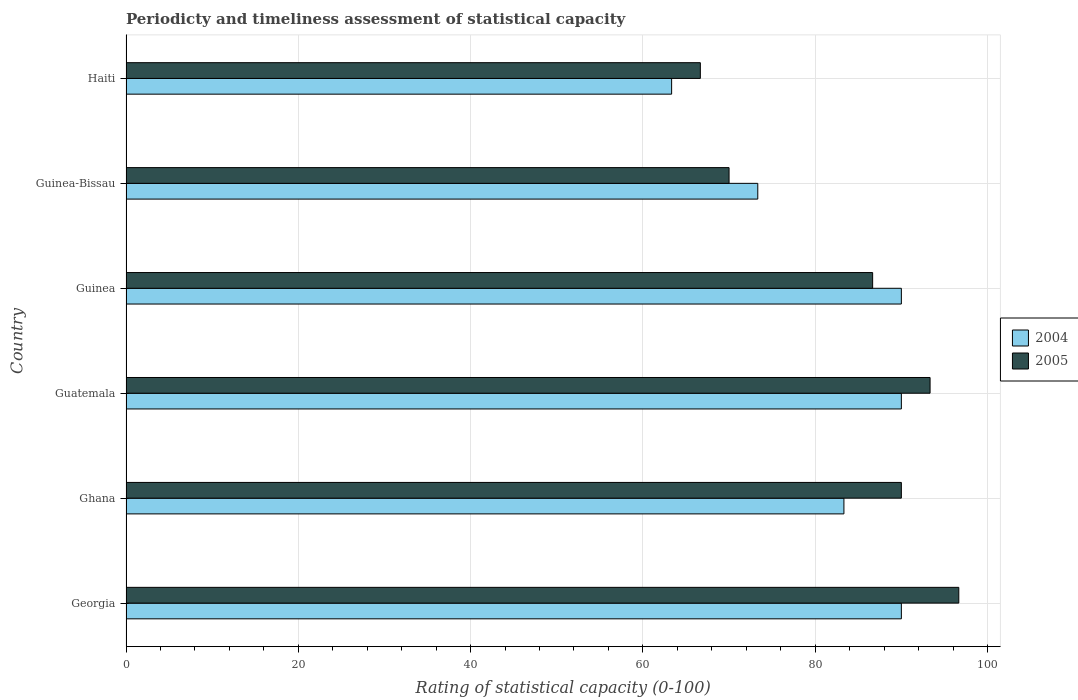How many groups of bars are there?
Make the answer very short. 6. Are the number of bars per tick equal to the number of legend labels?
Make the answer very short. Yes. How many bars are there on the 5th tick from the top?
Ensure brevity in your answer.  2. What is the label of the 2nd group of bars from the top?
Your answer should be compact. Guinea-Bissau. In how many cases, is the number of bars for a given country not equal to the number of legend labels?
Keep it short and to the point. 0. What is the rating of statistical capacity in 2005 in Ghana?
Offer a very short reply. 90. Across all countries, what is the maximum rating of statistical capacity in 2005?
Offer a very short reply. 96.67. Across all countries, what is the minimum rating of statistical capacity in 2004?
Your answer should be very brief. 63.33. In which country was the rating of statistical capacity in 2004 maximum?
Your response must be concise. Georgia. In which country was the rating of statistical capacity in 2004 minimum?
Ensure brevity in your answer.  Haiti. What is the total rating of statistical capacity in 2005 in the graph?
Offer a very short reply. 503.33. What is the difference between the rating of statistical capacity in 2005 in Haiti and the rating of statistical capacity in 2004 in Georgia?
Provide a short and direct response. -23.33. What is the average rating of statistical capacity in 2005 per country?
Provide a succinct answer. 83.89. What is the difference between the rating of statistical capacity in 2005 and rating of statistical capacity in 2004 in Guatemala?
Offer a very short reply. 3.33. What is the ratio of the rating of statistical capacity in 2004 in Georgia to that in Ghana?
Your answer should be compact. 1.08. What is the difference between the highest and the second highest rating of statistical capacity in 2005?
Provide a succinct answer. 3.33. What is the difference between the highest and the lowest rating of statistical capacity in 2004?
Your answer should be compact. 26.67. What does the 2nd bar from the bottom in Guinea represents?
Offer a terse response. 2005. Are the values on the major ticks of X-axis written in scientific E-notation?
Give a very brief answer. No. Does the graph contain grids?
Keep it short and to the point. Yes. How many legend labels are there?
Offer a very short reply. 2. What is the title of the graph?
Give a very brief answer. Periodicty and timeliness assessment of statistical capacity. Does "1986" appear as one of the legend labels in the graph?
Offer a very short reply. No. What is the label or title of the X-axis?
Offer a terse response. Rating of statistical capacity (0-100). What is the label or title of the Y-axis?
Your answer should be compact. Country. What is the Rating of statistical capacity (0-100) in 2004 in Georgia?
Keep it short and to the point. 90. What is the Rating of statistical capacity (0-100) in 2005 in Georgia?
Give a very brief answer. 96.67. What is the Rating of statistical capacity (0-100) in 2004 in Ghana?
Provide a succinct answer. 83.33. What is the Rating of statistical capacity (0-100) in 2005 in Ghana?
Offer a terse response. 90. What is the Rating of statistical capacity (0-100) of 2005 in Guatemala?
Ensure brevity in your answer.  93.33. What is the Rating of statistical capacity (0-100) of 2004 in Guinea?
Make the answer very short. 90. What is the Rating of statistical capacity (0-100) of 2005 in Guinea?
Your answer should be very brief. 86.67. What is the Rating of statistical capacity (0-100) in 2004 in Guinea-Bissau?
Ensure brevity in your answer.  73.33. What is the Rating of statistical capacity (0-100) in 2005 in Guinea-Bissau?
Your answer should be compact. 70. What is the Rating of statistical capacity (0-100) in 2004 in Haiti?
Make the answer very short. 63.33. What is the Rating of statistical capacity (0-100) of 2005 in Haiti?
Your response must be concise. 66.67. Across all countries, what is the maximum Rating of statistical capacity (0-100) of 2005?
Provide a short and direct response. 96.67. Across all countries, what is the minimum Rating of statistical capacity (0-100) in 2004?
Provide a short and direct response. 63.33. Across all countries, what is the minimum Rating of statistical capacity (0-100) of 2005?
Your answer should be very brief. 66.67. What is the total Rating of statistical capacity (0-100) in 2004 in the graph?
Keep it short and to the point. 490. What is the total Rating of statistical capacity (0-100) in 2005 in the graph?
Your answer should be compact. 503.33. What is the difference between the Rating of statistical capacity (0-100) in 2004 in Georgia and that in Guatemala?
Offer a terse response. 0. What is the difference between the Rating of statistical capacity (0-100) in 2004 in Georgia and that in Guinea?
Provide a succinct answer. 0. What is the difference between the Rating of statistical capacity (0-100) of 2004 in Georgia and that in Guinea-Bissau?
Provide a succinct answer. 16.67. What is the difference between the Rating of statistical capacity (0-100) of 2005 in Georgia and that in Guinea-Bissau?
Offer a very short reply. 26.67. What is the difference between the Rating of statistical capacity (0-100) in 2004 in Georgia and that in Haiti?
Offer a very short reply. 26.67. What is the difference between the Rating of statistical capacity (0-100) of 2005 in Georgia and that in Haiti?
Provide a succinct answer. 30. What is the difference between the Rating of statistical capacity (0-100) in 2004 in Ghana and that in Guatemala?
Keep it short and to the point. -6.67. What is the difference between the Rating of statistical capacity (0-100) of 2004 in Ghana and that in Guinea?
Provide a short and direct response. -6.67. What is the difference between the Rating of statistical capacity (0-100) of 2005 in Ghana and that in Guinea?
Offer a terse response. 3.33. What is the difference between the Rating of statistical capacity (0-100) in 2005 in Ghana and that in Guinea-Bissau?
Ensure brevity in your answer.  20. What is the difference between the Rating of statistical capacity (0-100) of 2005 in Ghana and that in Haiti?
Provide a succinct answer. 23.33. What is the difference between the Rating of statistical capacity (0-100) of 2005 in Guatemala and that in Guinea?
Offer a terse response. 6.67. What is the difference between the Rating of statistical capacity (0-100) of 2004 in Guatemala and that in Guinea-Bissau?
Provide a succinct answer. 16.67. What is the difference between the Rating of statistical capacity (0-100) of 2005 in Guatemala and that in Guinea-Bissau?
Offer a terse response. 23.33. What is the difference between the Rating of statistical capacity (0-100) of 2004 in Guatemala and that in Haiti?
Keep it short and to the point. 26.67. What is the difference between the Rating of statistical capacity (0-100) in 2005 in Guatemala and that in Haiti?
Ensure brevity in your answer.  26.67. What is the difference between the Rating of statistical capacity (0-100) of 2004 in Guinea and that in Guinea-Bissau?
Keep it short and to the point. 16.67. What is the difference between the Rating of statistical capacity (0-100) in 2005 in Guinea and that in Guinea-Bissau?
Give a very brief answer. 16.67. What is the difference between the Rating of statistical capacity (0-100) in 2004 in Guinea and that in Haiti?
Keep it short and to the point. 26.67. What is the difference between the Rating of statistical capacity (0-100) in 2005 in Guinea-Bissau and that in Haiti?
Keep it short and to the point. 3.33. What is the difference between the Rating of statistical capacity (0-100) of 2004 in Georgia and the Rating of statistical capacity (0-100) of 2005 in Guinea?
Provide a short and direct response. 3.33. What is the difference between the Rating of statistical capacity (0-100) in 2004 in Georgia and the Rating of statistical capacity (0-100) in 2005 in Guinea-Bissau?
Your response must be concise. 20. What is the difference between the Rating of statistical capacity (0-100) of 2004 in Georgia and the Rating of statistical capacity (0-100) of 2005 in Haiti?
Make the answer very short. 23.33. What is the difference between the Rating of statistical capacity (0-100) in 2004 in Ghana and the Rating of statistical capacity (0-100) in 2005 in Guinea-Bissau?
Offer a terse response. 13.33. What is the difference between the Rating of statistical capacity (0-100) of 2004 in Ghana and the Rating of statistical capacity (0-100) of 2005 in Haiti?
Your answer should be compact. 16.67. What is the difference between the Rating of statistical capacity (0-100) of 2004 in Guatemala and the Rating of statistical capacity (0-100) of 2005 in Haiti?
Your answer should be compact. 23.33. What is the difference between the Rating of statistical capacity (0-100) in 2004 in Guinea and the Rating of statistical capacity (0-100) in 2005 in Guinea-Bissau?
Offer a very short reply. 20. What is the difference between the Rating of statistical capacity (0-100) of 2004 in Guinea and the Rating of statistical capacity (0-100) of 2005 in Haiti?
Offer a terse response. 23.33. What is the difference between the Rating of statistical capacity (0-100) in 2004 in Guinea-Bissau and the Rating of statistical capacity (0-100) in 2005 in Haiti?
Offer a very short reply. 6.67. What is the average Rating of statistical capacity (0-100) in 2004 per country?
Make the answer very short. 81.67. What is the average Rating of statistical capacity (0-100) of 2005 per country?
Your response must be concise. 83.89. What is the difference between the Rating of statistical capacity (0-100) of 2004 and Rating of statistical capacity (0-100) of 2005 in Georgia?
Your response must be concise. -6.67. What is the difference between the Rating of statistical capacity (0-100) of 2004 and Rating of statistical capacity (0-100) of 2005 in Ghana?
Offer a very short reply. -6.67. What is the difference between the Rating of statistical capacity (0-100) of 2004 and Rating of statistical capacity (0-100) of 2005 in Guinea?
Your answer should be compact. 3.33. What is the difference between the Rating of statistical capacity (0-100) in 2004 and Rating of statistical capacity (0-100) in 2005 in Haiti?
Offer a terse response. -3.33. What is the ratio of the Rating of statistical capacity (0-100) in 2004 in Georgia to that in Ghana?
Offer a terse response. 1.08. What is the ratio of the Rating of statistical capacity (0-100) in 2005 in Georgia to that in Ghana?
Ensure brevity in your answer.  1.07. What is the ratio of the Rating of statistical capacity (0-100) of 2005 in Georgia to that in Guatemala?
Your answer should be compact. 1.04. What is the ratio of the Rating of statistical capacity (0-100) of 2005 in Georgia to that in Guinea?
Ensure brevity in your answer.  1.12. What is the ratio of the Rating of statistical capacity (0-100) in 2004 in Georgia to that in Guinea-Bissau?
Keep it short and to the point. 1.23. What is the ratio of the Rating of statistical capacity (0-100) of 2005 in Georgia to that in Guinea-Bissau?
Offer a terse response. 1.38. What is the ratio of the Rating of statistical capacity (0-100) of 2004 in Georgia to that in Haiti?
Offer a terse response. 1.42. What is the ratio of the Rating of statistical capacity (0-100) in 2005 in Georgia to that in Haiti?
Keep it short and to the point. 1.45. What is the ratio of the Rating of statistical capacity (0-100) of 2004 in Ghana to that in Guatemala?
Give a very brief answer. 0.93. What is the ratio of the Rating of statistical capacity (0-100) of 2005 in Ghana to that in Guatemala?
Give a very brief answer. 0.96. What is the ratio of the Rating of statistical capacity (0-100) in 2004 in Ghana to that in Guinea?
Your answer should be compact. 0.93. What is the ratio of the Rating of statistical capacity (0-100) of 2005 in Ghana to that in Guinea?
Offer a very short reply. 1.04. What is the ratio of the Rating of statistical capacity (0-100) of 2004 in Ghana to that in Guinea-Bissau?
Offer a very short reply. 1.14. What is the ratio of the Rating of statistical capacity (0-100) in 2005 in Ghana to that in Guinea-Bissau?
Your response must be concise. 1.29. What is the ratio of the Rating of statistical capacity (0-100) of 2004 in Ghana to that in Haiti?
Make the answer very short. 1.32. What is the ratio of the Rating of statistical capacity (0-100) of 2005 in Ghana to that in Haiti?
Offer a terse response. 1.35. What is the ratio of the Rating of statistical capacity (0-100) in 2004 in Guatemala to that in Guinea?
Provide a succinct answer. 1. What is the ratio of the Rating of statistical capacity (0-100) of 2005 in Guatemala to that in Guinea?
Keep it short and to the point. 1.08. What is the ratio of the Rating of statistical capacity (0-100) in 2004 in Guatemala to that in Guinea-Bissau?
Offer a terse response. 1.23. What is the ratio of the Rating of statistical capacity (0-100) in 2005 in Guatemala to that in Guinea-Bissau?
Your response must be concise. 1.33. What is the ratio of the Rating of statistical capacity (0-100) in 2004 in Guatemala to that in Haiti?
Offer a terse response. 1.42. What is the ratio of the Rating of statistical capacity (0-100) in 2005 in Guatemala to that in Haiti?
Ensure brevity in your answer.  1.4. What is the ratio of the Rating of statistical capacity (0-100) in 2004 in Guinea to that in Guinea-Bissau?
Give a very brief answer. 1.23. What is the ratio of the Rating of statistical capacity (0-100) of 2005 in Guinea to that in Guinea-Bissau?
Offer a very short reply. 1.24. What is the ratio of the Rating of statistical capacity (0-100) of 2004 in Guinea to that in Haiti?
Offer a terse response. 1.42. What is the ratio of the Rating of statistical capacity (0-100) of 2005 in Guinea to that in Haiti?
Your response must be concise. 1.3. What is the ratio of the Rating of statistical capacity (0-100) in 2004 in Guinea-Bissau to that in Haiti?
Make the answer very short. 1.16. What is the difference between the highest and the lowest Rating of statistical capacity (0-100) in 2004?
Give a very brief answer. 26.67. What is the difference between the highest and the lowest Rating of statistical capacity (0-100) in 2005?
Provide a short and direct response. 30. 